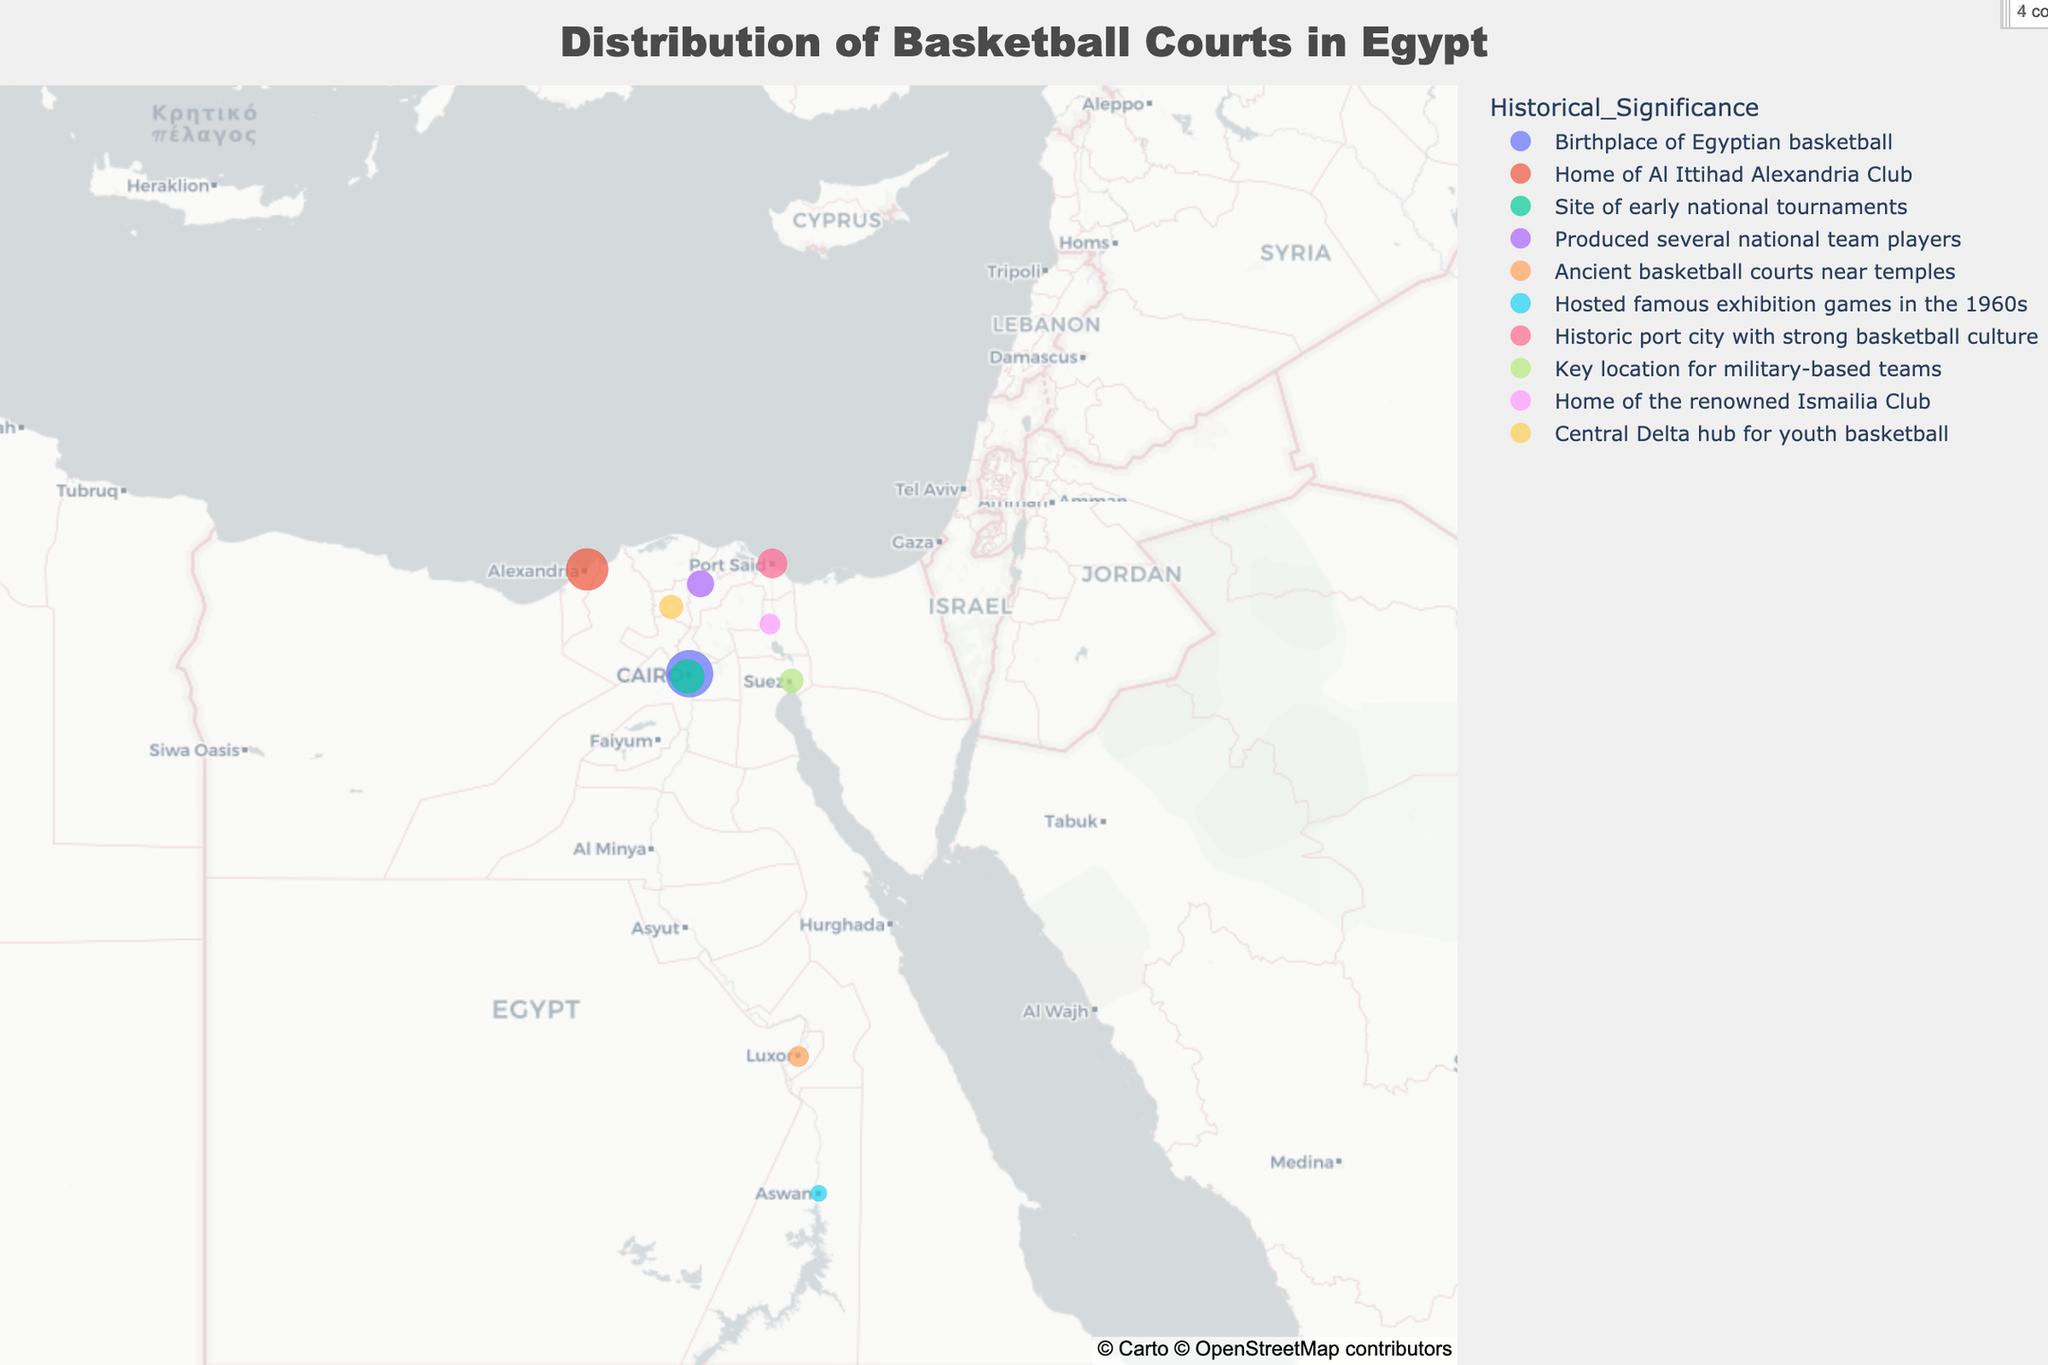Which region has the highest number of basketball courts? The figure visually represents the number of basketball courts by the size of the markers. The largest marker corresponds to Cairo.
Answer: Cairo What is the title of the figure? The title is displayed at the top center of the figure.
Answer: Distribution of Basketball Courts in Egypt Aside from Cairo, which region has a high concentration of basketball courts and historical significance? The next largest marker after Cairo, indicating both high concentration of courts and historical significance, is in Alexandria.
Answer: Alexandria Which regions have only 3 basketball courts? The figure shows markers of similar size at Luxor and Ismailia corresponding to 3 courts each.
Answer: Luxor and Ismailia What is the total number of basketball courts in Giza and Port Said? Giza has 8 courts, and Port Said has 6 courts. Adding them together: 8 + 6 = 14.
Answer: 14 Which region is historically significant for being the home of a renowned basketball club? Hovering over the markers reveals that Ismailia is historically significant as the home of the renowned Ismailia Club.
Answer: Ismailia How many basketball courts are present in regions with the least historical significance, assuming these are regions with 2 or fewer courts? Only Aswan has 2 courts, and there are no regions with fewer than 2.
Answer: 2 Compare the historical significance of Alexandria and Cairo in basketball. Which one is the birthplace of Egyptian basketball? Hovering over the markers reveals that Cairo is the birthplace of Egyptian basketball. Alexandria is home to the Al Ittihad Alexandria Club.
Answer: Cairo Which region in the Delta is a hub for youth basketball, and how many courts does it have? Hovering over the relevant markers, Tanta is revealed as the central Delta hub for youth basketball and has 4 courts.
Answer: Tanta, 4 What is the geographical relationship between the number of courts and historical significance in southern regions like Luxor and Aswan? Luxor and Aswan have fewer courts (3 and 2, respectively) but are marked with historical significance related to ancient courts and exhibition games.
Answer: Fewer courts, significant history 